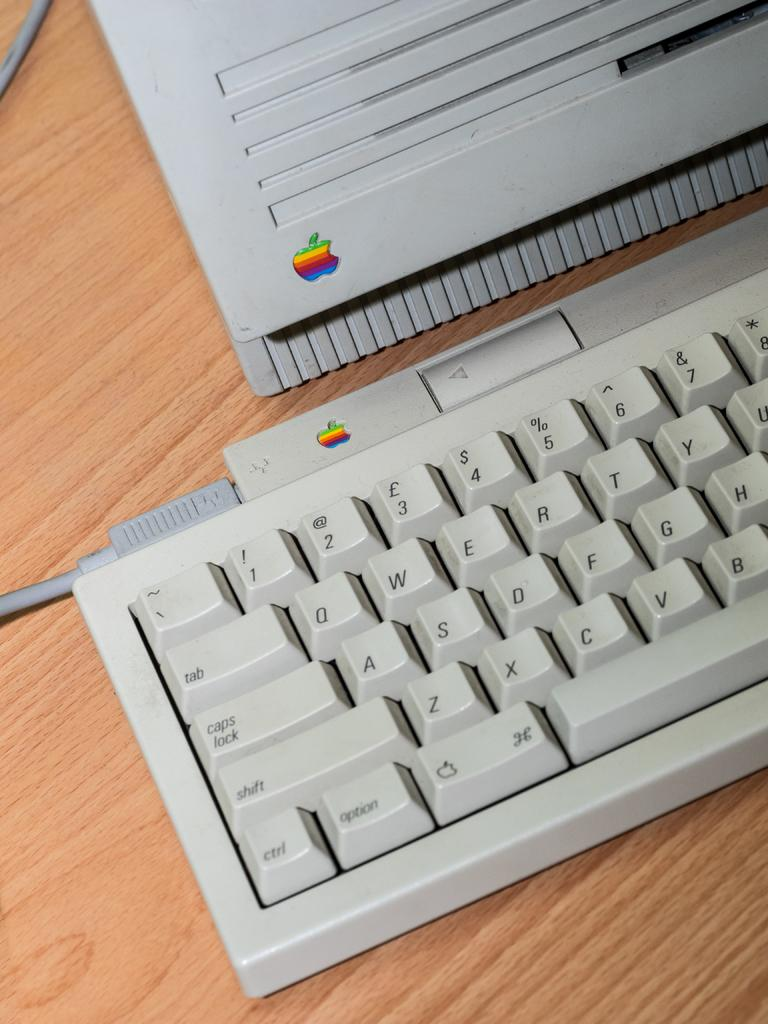<image>
Provide a brief description of the given image. A computer keyboard with the tab key visible 